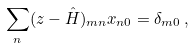Convert formula to latex. <formula><loc_0><loc_0><loc_500><loc_500>\sum _ { n } ( z - \hat { H } ) _ { m n } x _ { n 0 } = \delta _ { m 0 } \, ,</formula> 